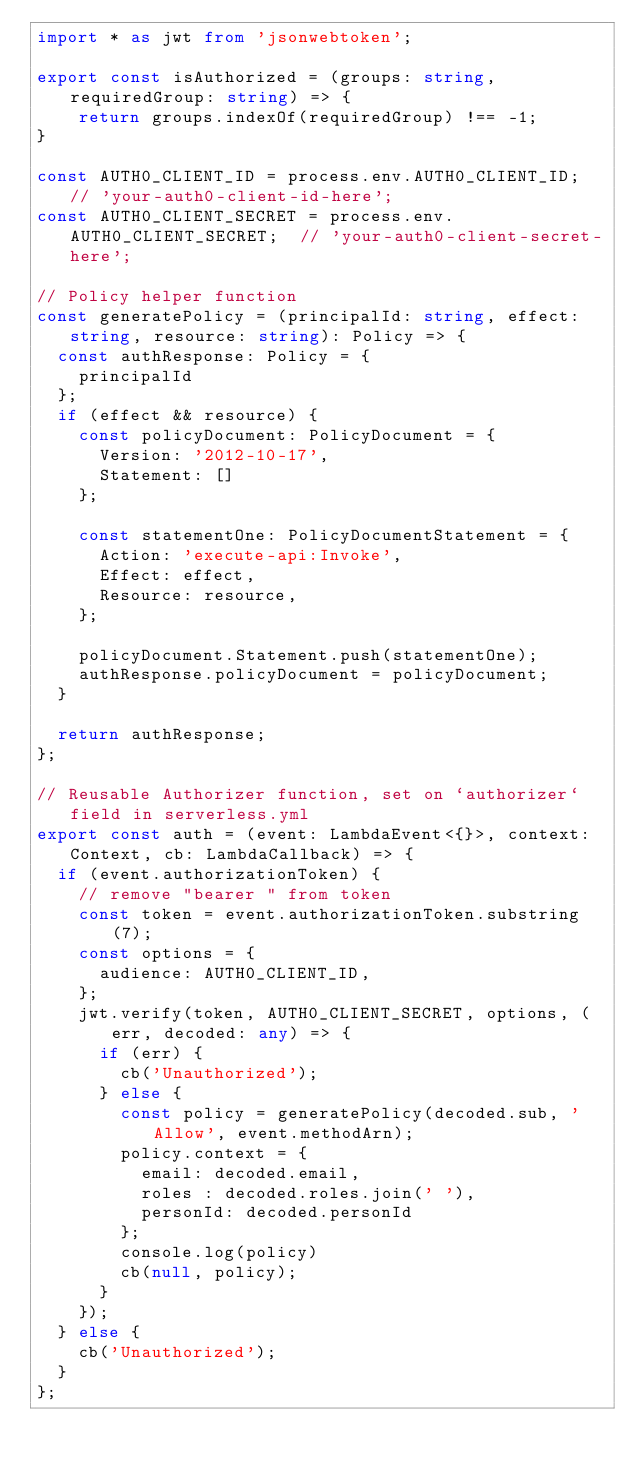<code> <loc_0><loc_0><loc_500><loc_500><_TypeScript_>import * as jwt from 'jsonwebtoken';

export const isAuthorized = (groups: string, requiredGroup: string) => {
    return groups.indexOf(requiredGroup) !== -1;
}

const AUTH0_CLIENT_ID = process.env.AUTH0_CLIENT_ID; // 'your-auth0-client-id-here';
const AUTH0_CLIENT_SECRET = process.env.AUTH0_CLIENT_SECRET;  // 'your-auth0-client-secret-here';

// Policy helper function
const generatePolicy = (principalId: string, effect: string, resource: string): Policy => {
  const authResponse: Policy = {
    principalId
  };
  if (effect && resource) { 
    const policyDocument: PolicyDocument = {
      Version: '2012-10-17',
      Statement: []
    };

    const statementOne: PolicyDocumentStatement = {
      Action: 'execute-api:Invoke',
      Effect: effect,
      Resource: resource,
    };

    policyDocument.Statement.push(statementOne);
    authResponse.policyDocument = policyDocument;
  }
  
  return authResponse;
};

// Reusable Authorizer function, set on `authorizer` field in serverless.yml
export const auth = (event: LambdaEvent<{}>, context: Context, cb: LambdaCallback) => {
  if (event.authorizationToken) {
    // remove "bearer " from token
    const token = event.authorizationToken.substring(7);
    const options = {
      audience: AUTH0_CLIENT_ID,
    };
    jwt.verify(token, AUTH0_CLIENT_SECRET, options, (err, decoded: any) => {
      if (err) {
        cb('Unauthorized');
      } else {
        const policy = generatePolicy(decoded.sub, 'Allow', event.methodArn);
        policy.context = {
          email: decoded.email,
          roles : decoded.roles.join(' '),
          personId: decoded.personId
        };
        console.log(policy)
        cb(null, policy);
      }
    });
  } else {
    cb('Unauthorized');
  }
};</code> 